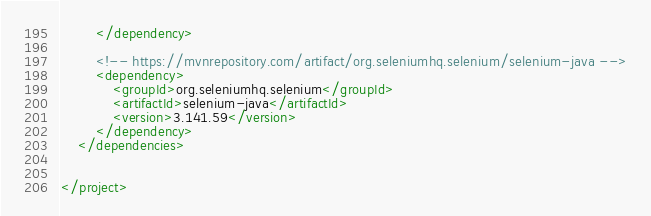<code> <loc_0><loc_0><loc_500><loc_500><_XML_>		</dependency>

		<!-- https://mvnrepository.com/artifact/org.seleniumhq.selenium/selenium-java -->
		<dependency>
			<groupId>org.seleniumhq.selenium</groupId>
			<artifactId>selenium-java</artifactId>
			<version>3.141.59</version>
		</dependency>
	</dependencies>


</project></code> 